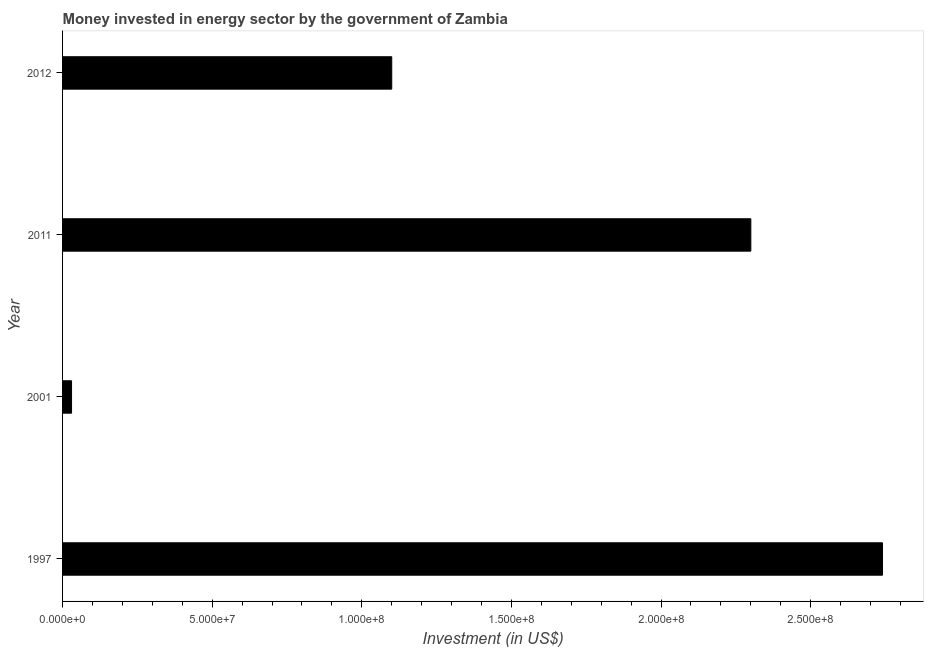Does the graph contain grids?
Your answer should be compact. No. What is the title of the graph?
Offer a terse response. Money invested in energy sector by the government of Zambia. What is the label or title of the X-axis?
Your answer should be very brief. Investment (in US$). What is the label or title of the Y-axis?
Offer a terse response. Year. What is the investment in energy in 1997?
Give a very brief answer. 2.74e+08. Across all years, what is the maximum investment in energy?
Provide a succinct answer. 2.74e+08. In which year was the investment in energy maximum?
Keep it short and to the point. 1997. What is the sum of the investment in energy?
Keep it short and to the point. 6.17e+08. What is the difference between the investment in energy in 2011 and 2012?
Make the answer very short. 1.20e+08. What is the average investment in energy per year?
Your response must be concise. 1.54e+08. What is the median investment in energy?
Ensure brevity in your answer.  1.70e+08. In how many years, is the investment in energy greater than 200000000 US$?
Your answer should be compact. 2. Do a majority of the years between 2001 and 2012 (inclusive) have investment in energy greater than 180000000 US$?
Make the answer very short. No. What is the ratio of the investment in energy in 2011 to that in 2012?
Give a very brief answer. 2.09. What is the difference between the highest and the second highest investment in energy?
Give a very brief answer. 4.40e+07. What is the difference between the highest and the lowest investment in energy?
Your response must be concise. 2.71e+08. How many bars are there?
Offer a terse response. 4. Are all the bars in the graph horizontal?
Ensure brevity in your answer.  Yes. What is the difference between two consecutive major ticks on the X-axis?
Keep it short and to the point. 5.00e+07. Are the values on the major ticks of X-axis written in scientific E-notation?
Keep it short and to the point. Yes. What is the Investment (in US$) of 1997?
Your answer should be compact. 2.74e+08. What is the Investment (in US$) of 2001?
Your answer should be very brief. 3.00e+06. What is the Investment (in US$) in 2011?
Your answer should be very brief. 2.30e+08. What is the Investment (in US$) of 2012?
Ensure brevity in your answer.  1.10e+08. What is the difference between the Investment (in US$) in 1997 and 2001?
Provide a short and direct response. 2.71e+08. What is the difference between the Investment (in US$) in 1997 and 2011?
Ensure brevity in your answer.  4.40e+07. What is the difference between the Investment (in US$) in 1997 and 2012?
Make the answer very short. 1.64e+08. What is the difference between the Investment (in US$) in 2001 and 2011?
Offer a very short reply. -2.27e+08. What is the difference between the Investment (in US$) in 2001 and 2012?
Offer a terse response. -1.07e+08. What is the difference between the Investment (in US$) in 2011 and 2012?
Your response must be concise. 1.20e+08. What is the ratio of the Investment (in US$) in 1997 to that in 2001?
Keep it short and to the point. 91.33. What is the ratio of the Investment (in US$) in 1997 to that in 2011?
Your response must be concise. 1.19. What is the ratio of the Investment (in US$) in 1997 to that in 2012?
Ensure brevity in your answer.  2.49. What is the ratio of the Investment (in US$) in 2001 to that in 2011?
Your answer should be very brief. 0.01. What is the ratio of the Investment (in US$) in 2001 to that in 2012?
Provide a succinct answer. 0.03. What is the ratio of the Investment (in US$) in 2011 to that in 2012?
Provide a succinct answer. 2.09. 